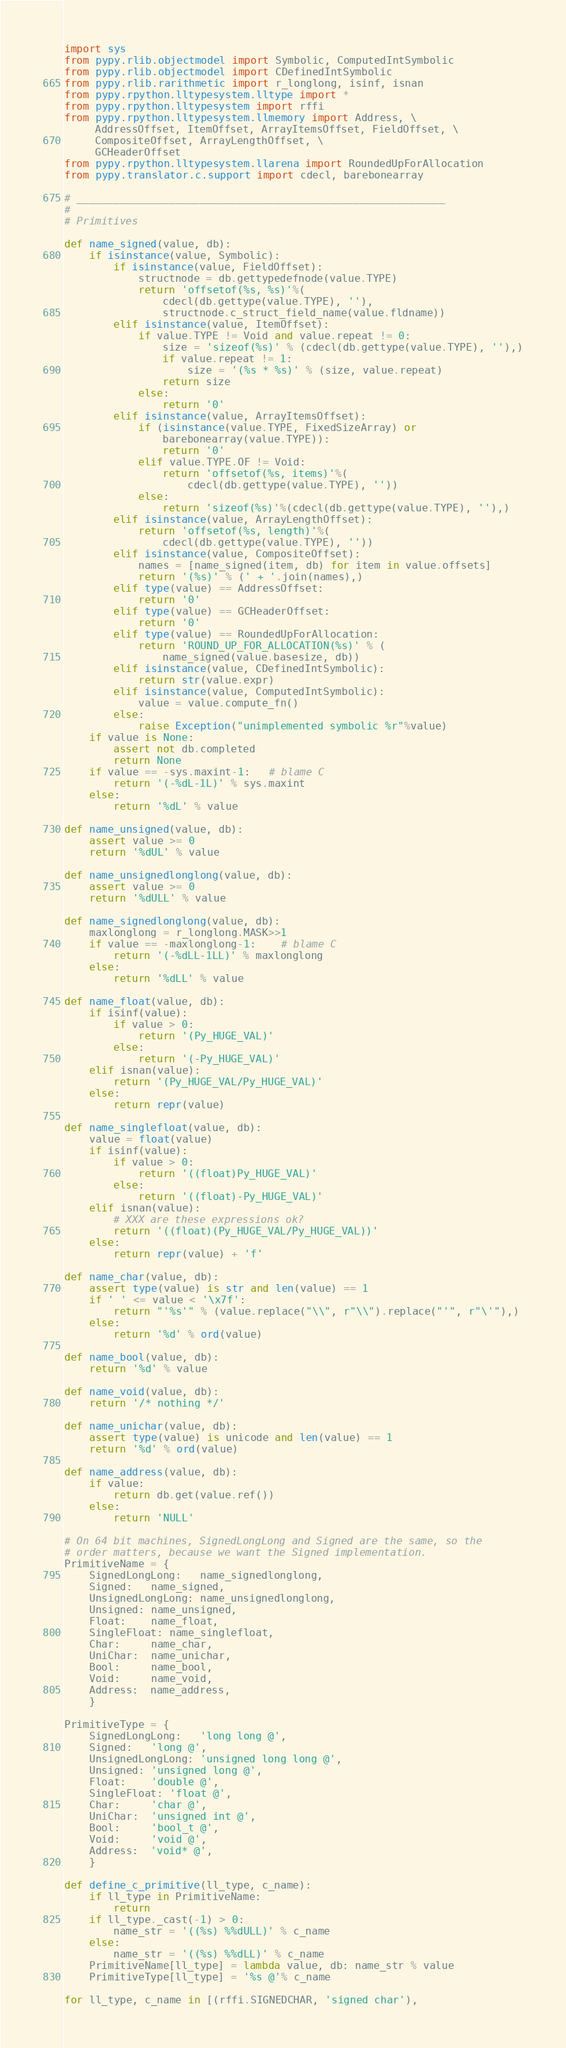Convert code to text. <code><loc_0><loc_0><loc_500><loc_500><_Python_>import sys
from pypy.rlib.objectmodel import Symbolic, ComputedIntSymbolic
from pypy.rlib.objectmodel import CDefinedIntSymbolic
from pypy.rlib.rarithmetic import r_longlong, isinf, isnan
from pypy.rpython.lltypesystem.lltype import *
from pypy.rpython.lltypesystem import rffi
from pypy.rpython.lltypesystem.llmemory import Address, \
     AddressOffset, ItemOffset, ArrayItemsOffset, FieldOffset, \
     CompositeOffset, ArrayLengthOffset, \
     GCHeaderOffset
from pypy.rpython.lltypesystem.llarena import RoundedUpForAllocation
from pypy.translator.c.support import cdecl, barebonearray

# ____________________________________________________________
#
# Primitives

def name_signed(value, db):
    if isinstance(value, Symbolic):
        if isinstance(value, FieldOffset):
            structnode = db.gettypedefnode(value.TYPE)
            return 'offsetof(%s, %s)'%(
                cdecl(db.gettype(value.TYPE), ''),
                structnode.c_struct_field_name(value.fldname))
        elif isinstance(value, ItemOffset):
            if value.TYPE != Void and value.repeat != 0:
                size = 'sizeof(%s)' % (cdecl(db.gettype(value.TYPE), ''),)
                if value.repeat != 1:
                    size = '(%s * %s)' % (size, value.repeat)
                return size
            else:
                return '0'
        elif isinstance(value, ArrayItemsOffset):
            if (isinstance(value.TYPE, FixedSizeArray) or
                barebonearray(value.TYPE)):
                return '0'
            elif value.TYPE.OF != Void:
                return 'offsetof(%s, items)'%(
                    cdecl(db.gettype(value.TYPE), ''))
            else:
                return 'sizeof(%s)'%(cdecl(db.gettype(value.TYPE), ''),)
        elif isinstance(value, ArrayLengthOffset):
            return 'offsetof(%s, length)'%(
                cdecl(db.gettype(value.TYPE), ''))
        elif isinstance(value, CompositeOffset):
            names = [name_signed(item, db) for item in value.offsets]
            return '(%s)' % (' + '.join(names),)
        elif type(value) == AddressOffset:
            return '0'
        elif type(value) == GCHeaderOffset:
            return '0'
        elif type(value) == RoundedUpForAllocation:
            return 'ROUND_UP_FOR_ALLOCATION(%s)' % (
                name_signed(value.basesize, db))
        elif isinstance(value, CDefinedIntSymbolic):
            return str(value.expr)
        elif isinstance(value, ComputedIntSymbolic):
            value = value.compute_fn()
        else:
            raise Exception("unimplemented symbolic %r"%value)
    if value is None:
        assert not db.completed
        return None
    if value == -sys.maxint-1:   # blame C
        return '(-%dL-1L)' % sys.maxint
    else:
        return '%dL' % value

def name_unsigned(value, db):
    assert value >= 0
    return '%dUL' % value

def name_unsignedlonglong(value, db):
    assert value >= 0
    return '%dULL' % value

def name_signedlonglong(value, db):
    maxlonglong = r_longlong.MASK>>1
    if value == -maxlonglong-1:    # blame C
        return '(-%dLL-1LL)' % maxlonglong
    else:
        return '%dLL' % value

def name_float(value, db):
    if isinf(value):
        if value > 0:
            return '(Py_HUGE_VAL)'
        else:
            return '(-Py_HUGE_VAL)'
    elif isnan(value):
        return '(Py_HUGE_VAL/Py_HUGE_VAL)'
    else:
        return repr(value)

def name_singlefloat(value, db):
    value = float(value)
    if isinf(value):
        if value > 0:
            return '((float)Py_HUGE_VAL)'
        else:
            return '((float)-Py_HUGE_VAL)'
    elif isnan(value):
        # XXX are these expressions ok?
        return '((float)(Py_HUGE_VAL/Py_HUGE_VAL))'
    else:
        return repr(value) + 'f'

def name_char(value, db):
    assert type(value) is str and len(value) == 1
    if ' ' <= value < '\x7f':
        return "'%s'" % (value.replace("\\", r"\\").replace("'", r"\'"),)
    else:
        return '%d' % ord(value)

def name_bool(value, db):
    return '%d' % value

def name_void(value, db):
    return '/* nothing */'

def name_unichar(value, db):
    assert type(value) is unicode and len(value) == 1
    return '%d' % ord(value)

def name_address(value, db):
    if value:
        return db.get(value.ref())
    else:
        return 'NULL'

# On 64 bit machines, SignedLongLong and Signed are the same, so the
# order matters, because we want the Signed implementation.
PrimitiveName = {
    SignedLongLong:   name_signedlonglong,
    Signed:   name_signed,
    UnsignedLongLong: name_unsignedlonglong,
    Unsigned: name_unsigned,
    Float:    name_float,
    SingleFloat: name_singlefloat,
    Char:     name_char,
    UniChar:  name_unichar,
    Bool:     name_bool,
    Void:     name_void,
    Address:  name_address,
    }

PrimitiveType = {
    SignedLongLong:   'long long @',
    Signed:   'long @',
    UnsignedLongLong: 'unsigned long long @',
    Unsigned: 'unsigned long @',
    Float:    'double @',
    SingleFloat: 'float @',
    Char:     'char @',
    UniChar:  'unsigned int @',
    Bool:     'bool_t @',
    Void:     'void @',
    Address:  'void* @',
    }

def define_c_primitive(ll_type, c_name):
    if ll_type in PrimitiveName:
        return
    if ll_type._cast(-1) > 0:
        name_str = '((%s) %%dULL)' % c_name
    else:
        name_str = '((%s) %%dLL)' % c_name
    PrimitiveName[ll_type] = lambda value, db: name_str % value
    PrimitiveType[ll_type] = '%s @'% c_name
    
for ll_type, c_name in [(rffi.SIGNEDCHAR, 'signed char'),</code> 